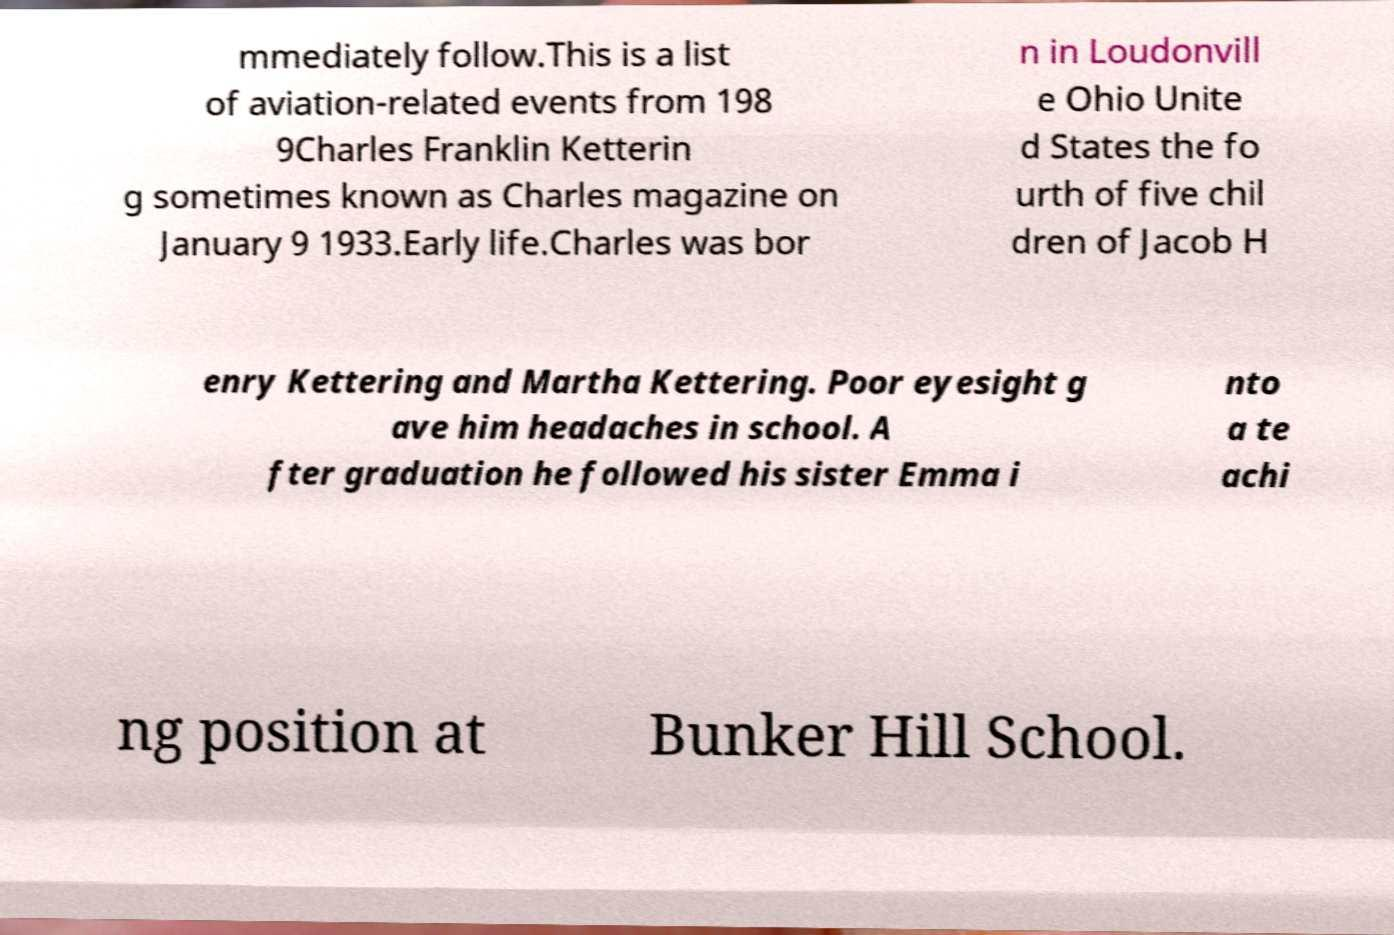What messages or text are displayed in this image? I need them in a readable, typed format. mmediately follow.This is a list of aviation-related events from 198 9Charles Franklin Ketterin g sometimes known as Charles magazine on January 9 1933.Early life.Charles was bor n in Loudonvill e Ohio Unite d States the fo urth of five chil dren of Jacob H enry Kettering and Martha Kettering. Poor eyesight g ave him headaches in school. A fter graduation he followed his sister Emma i nto a te achi ng position at Bunker Hill School. 